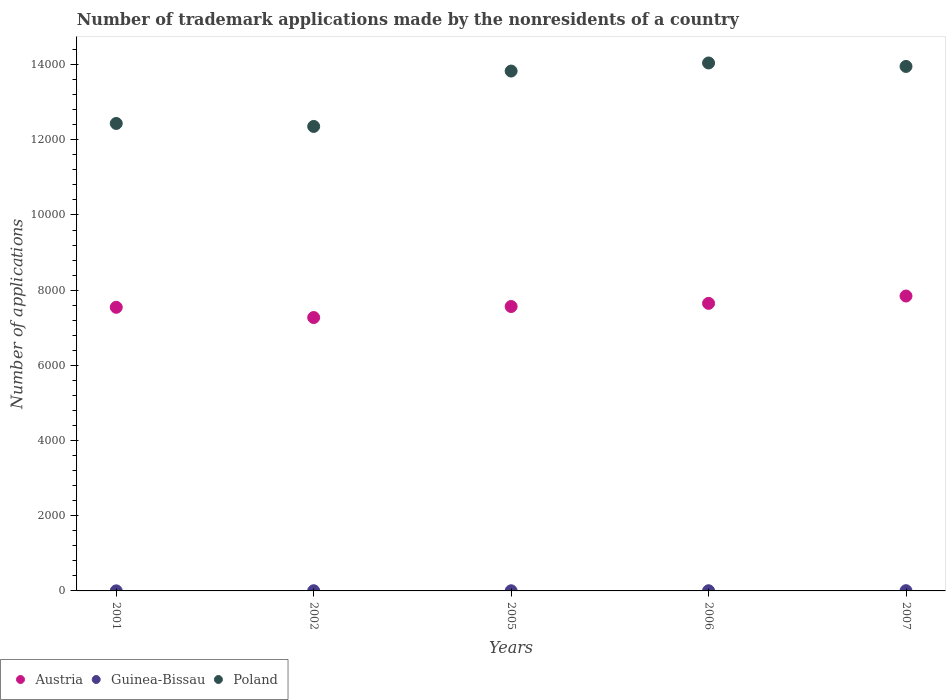Is the number of dotlines equal to the number of legend labels?
Provide a short and direct response. Yes. What is the number of trademark applications made by the nonresidents in Poland in 2001?
Your response must be concise. 1.24e+04. In which year was the number of trademark applications made by the nonresidents in Austria maximum?
Offer a very short reply. 2007. What is the total number of trademark applications made by the nonresidents in Poland in the graph?
Offer a very short reply. 6.66e+04. What is the difference between the number of trademark applications made by the nonresidents in Austria in 2005 and that in 2006?
Your response must be concise. -84. What is the difference between the number of trademark applications made by the nonresidents in Poland in 2005 and the number of trademark applications made by the nonresidents in Austria in 2001?
Provide a succinct answer. 6284. What is the average number of trademark applications made by the nonresidents in Austria per year?
Keep it short and to the point. 7574.8. In the year 2007, what is the difference between the number of trademark applications made by the nonresidents in Guinea-Bissau and number of trademark applications made by the nonresidents in Austria?
Your answer should be very brief. -7838. In how many years, is the number of trademark applications made by the nonresidents in Austria greater than 5200?
Make the answer very short. 5. What is the ratio of the number of trademark applications made by the nonresidents in Poland in 2001 to that in 2007?
Offer a very short reply. 0.89. What is the difference between the highest and the second highest number of trademark applications made by the nonresidents in Guinea-Bissau?
Provide a succinct answer. 1. What is the difference between the highest and the lowest number of trademark applications made by the nonresidents in Austria?
Provide a short and direct response. 572. In how many years, is the number of trademark applications made by the nonresidents in Guinea-Bissau greater than the average number of trademark applications made by the nonresidents in Guinea-Bissau taken over all years?
Make the answer very short. 3. Is the sum of the number of trademark applications made by the nonresidents in Austria in 2005 and 2006 greater than the maximum number of trademark applications made by the nonresidents in Guinea-Bissau across all years?
Your response must be concise. Yes. Is it the case that in every year, the sum of the number of trademark applications made by the nonresidents in Guinea-Bissau and number of trademark applications made by the nonresidents in Austria  is greater than the number of trademark applications made by the nonresidents in Poland?
Provide a short and direct response. No. Is the number of trademark applications made by the nonresidents in Poland strictly less than the number of trademark applications made by the nonresidents in Guinea-Bissau over the years?
Offer a terse response. No. How many dotlines are there?
Ensure brevity in your answer.  3. What is the difference between two consecutive major ticks on the Y-axis?
Make the answer very short. 2000. Does the graph contain any zero values?
Ensure brevity in your answer.  No. How many legend labels are there?
Offer a terse response. 3. How are the legend labels stacked?
Your answer should be very brief. Horizontal. What is the title of the graph?
Your answer should be very brief. Number of trademark applications made by the nonresidents of a country. What is the label or title of the X-axis?
Your response must be concise. Years. What is the label or title of the Y-axis?
Offer a very short reply. Number of applications. What is the Number of applications of Austria in 2001?
Offer a terse response. 7544. What is the Number of applications in Guinea-Bissau in 2001?
Your response must be concise. 2. What is the Number of applications in Poland in 2001?
Your answer should be very brief. 1.24e+04. What is the Number of applications in Austria in 2002?
Make the answer very short. 7272. What is the Number of applications of Poland in 2002?
Provide a succinct answer. 1.24e+04. What is the Number of applications of Austria in 2005?
Give a very brief answer. 7565. What is the Number of applications in Guinea-Bissau in 2005?
Your response must be concise. 4. What is the Number of applications in Poland in 2005?
Make the answer very short. 1.38e+04. What is the Number of applications of Austria in 2006?
Provide a short and direct response. 7649. What is the Number of applications of Guinea-Bissau in 2006?
Keep it short and to the point. 5. What is the Number of applications in Poland in 2006?
Your answer should be very brief. 1.40e+04. What is the Number of applications of Austria in 2007?
Provide a short and direct response. 7844. What is the Number of applications of Poland in 2007?
Your response must be concise. 1.40e+04. Across all years, what is the maximum Number of applications of Austria?
Provide a short and direct response. 7844. Across all years, what is the maximum Number of applications of Poland?
Ensure brevity in your answer.  1.40e+04. Across all years, what is the minimum Number of applications of Austria?
Your answer should be compact. 7272. Across all years, what is the minimum Number of applications in Poland?
Your response must be concise. 1.24e+04. What is the total Number of applications in Austria in the graph?
Provide a short and direct response. 3.79e+04. What is the total Number of applications of Guinea-Bissau in the graph?
Give a very brief answer. 22. What is the total Number of applications in Poland in the graph?
Make the answer very short. 6.66e+04. What is the difference between the Number of applications of Austria in 2001 and that in 2002?
Give a very brief answer. 272. What is the difference between the Number of applications in Guinea-Bissau in 2001 and that in 2002?
Your answer should be very brief. -3. What is the difference between the Number of applications in Poland in 2001 and that in 2002?
Offer a very short reply. 79. What is the difference between the Number of applications in Austria in 2001 and that in 2005?
Give a very brief answer. -21. What is the difference between the Number of applications of Poland in 2001 and that in 2005?
Ensure brevity in your answer.  -1394. What is the difference between the Number of applications in Austria in 2001 and that in 2006?
Make the answer very short. -105. What is the difference between the Number of applications in Guinea-Bissau in 2001 and that in 2006?
Ensure brevity in your answer.  -3. What is the difference between the Number of applications in Poland in 2001 and that in 2006?
Make the answer very short. -1609. What is the difference between the Number of applications of Austria in 2001 and that in 2007?
Provide a short and direct response. -300. What is the difference between the Number of applications of Poland in 2001 and that in 2007?
Provide a succinct answer. -1517. What is the difference between the Number of applications in Austria in 2002 and that in 2005?
Provide a succinct answer. -293. What is the difference between the Number of applications of Guinea-Bissau in 2002 and that in 2005?
Keep it short and to the point. 1. What is the difference between the Number of applications of Poland in 2002 and that in 2005?
Provide a succinct answer. -1473. What is the difference between the Number of applications in Austria in 2002 and that in 2006?
Give a very brief answer. -377. What is the difference between the Number of applications in Poland in 2002 and that in 2006?
Provide a succinct answer. -1688. What is the difference between the Number of applications of Austria in 2002 and that in 2007?
Provide a short and direct response. -572. What is the difference between the Number of applications of Poland in 2002 and that in 2007?
Keep it short and to the point. -1596. What is the difference between the Number of applications of Austria in 2005 and that in 2006?
Provide a succinct answer. -84. What is the difference between the Number of applications in Poland in 2005 and that in 2006?
Keep it short and to the point. -215. What is the difference between the Number of applications of Austria in 2005 and that in 2007?
Provide a succinct answer. -279. What is the difference between the Number of applications of Poland in 2005 and that in 2007?
Your answer should be compact. -123. What is the difference between the Number of applications of Austria in 2006 and that in 2007?
Offer a terse response. -195. What is the difference between the Number of applications in Poland in 2006 and that in 2007?
Provide a short and direct response. 92. What is the difference between the Number of applications in Austria in 2001 and the Number of applications in Guinea-Bissau in 2002?
Offer a terse response. 7539. What is the difference between the Number of applications in Austria in 2001 and the Number of applications in Poland in 2002?
Provide a short and direct response. -4811. What is the difference between the Number of applications in Guinea-Bissau in 2001 and the Number of applications in Poland in 2002?
Ensure brevity in your answer.  -1.24e+04. What is the difference between the Number of applications of Austria in 2001 and the Number of applications of Guinea-Bissau in 2005?
Keep it short and to the point. 7540. What is the difference between the Number of applications in Austria in 2001 and the Number of applications in Poland in 2005?
Keep it short and to the point. -6284. What is the difference between the Number of applications in Guinea-Bissau in 2001 and the Number of applications in Poland in 2005?
Your answer should be very brief. -1.38e+04. What is the difference between the Number of applications in Austria in 2001 and the Number of applications in Guinea-Bissau in 2006?
Your response must be concise. 7539. What is the difference between the Number of applications of Austria in 2001 and the Number of applications of Poland in 2006?
Your answer should be compact. -6499. What is the difference between the Number of applications of Guinea-Bissau in 2001 and the Number of applications of Poland in 2006?
Ensure brevity in your answer.  -1.40e+04. What is the difference between the Number of applications of Austria in 2001 and the Number of applications of Guinea-Bissau in 2007?
Make the answer very short. 7538. What is the difference between the Number of applications of Austria in 2001 and the Number of applications of Poland in 2007?
Provide a short and direct response. -6407. What is the difference between the Number of applications in Guinea-Bissau in 2001 and the Number of applications in Poland in 2007?
Your answer should be compact. -1.39e+04. What is the difference between the Number of applications of Austria in 2002 and the Number of applications of Guinea-Bissau in 2005?
Your response must be concise. 7268. What is the difference between the Number of applications of Austria in 2002 and the Number of applications of Poland in 2005?
Provide a succinct answer. -6556. What is the difference between the Number of applications in Guinea-Bissau in 2002 and the Number of applications in Poland in 2005?
Your response must be concise. -1.38e+04. What is the difference between the Number of applications of Austria in 2002 and the Number of applications of Guinea-Bissau in 2006?
Offer a very short reply. 7267. What is the difference between the Number of applications in Austria in 2002 and the Number of applications in Poland in 2006?
Provide a short and direct response. -6771. What is the difference between the Number of applications of Guinea-Bissau in 2002 and the Number of applications of Poland in 2006?
Offer a terse response. -1.40e+04. What is the difference between the Number of applications in Austria in 2002 and the Number of applications in Guinea-Bissau in 2007?
Ensure brevity in your answer.  7266. What is the difference between the Number of applications in Austria in 2002 and the Number of applications in Poland in 2007?
Keep it short and to the point. -6679. What is the difference between the Number of applications of Guinea-Bissau in 2002 and the Number of applications of Poland in 2007?
Offer a very short reply. -1.39e+04. What is the difference between the Number of applications in Austria in 2005 and the Number of applications in Guinea-Bissau in 2006?
Give a very brief answer. 7560. What is the difference between the Number of applications of Austria in 2005 and the Number of applications of Poland in 2006?
Make the answer very short. -6478. What is the difference between the Number of applications in Guinea-Bissau in 2005 and the Number of applications in Poland in 2006?
Provide a short and direct response. -1.40e+04. What is the difference between the Number of applications of Austria in 2005 and the Number of applications of Guinea-Bissau in 2007?
Give a very brief answer. 7559. What is the difference between the Number of applications of Austria in 2005 and the Number of applications of Poland in 2007?
Make the answer very short. -6386. What is the difference between the Number of applications of Guinea-Bissau in 2005 and the Number of applications of Poland in 2007?
Offer a very short reply. -1.39e+04. What is the difference between the Number of applications in Austria in 2006 and the Number of applications in Guinea-Bissau in 2007?
Provide a short and direct response. 7643. What is the difference between the Number of applications in Austria in 2006 and the Number of applications in Poland in 2007?
Your answer should be compact. -6302. What is the difference between the Number of applications in Guinea-Bissau in 2006 and the Number of applications in Poland in 2007?
Offer a terse response. -1.39e+04. What is the average Number of applications of Austria per year?
Make the answer very short. 7574.8. What is the average Number of applications of Guinea-Bissau per year?
Give a very brief answer. 4.4. What is the average Number of applications in Poland per year?
Ensure brevity in your answer.  1.33e+04. In the year 2001, what is the difference between the Number of applications in Austria and Number of applications in Guinea-Bissau?
Offer a very short reply. 7542. In the year 2001, what is the difference between the Number of applications of Austria and Number of applications of Poland?
Provide a short and direct response. -4890. In the year 2001, what is the difference between the Number of applications in Guinea-Bissau and Number of applications in Poland?
Your response must be concise. -1.24e+04. In the year 2002, what is the difference between the Number of applications of Austria and Number of applications of Guinea-Bissau?
Provide a succinct answer. 7267. In the year 2002, what is the difference between the Number of applications of Austria and Number of applications of Poland?
Give a very brief answer. -5083. In the year 2002, what is the difference between the Number of applications in Guinea-Bissau and Number of applications in Poland?
Provide a succinct answer. -1.24e+04. In the year 2005, what is the difference between the Number of applications of Austria and Number of applications of Guinea-Bissau?
Your response must be concise. 7561. In the year 2005, what is the difference between the Number of applications of Austria and Number of applications of Poland?
Make the answer very short. -6263. In the year 2005, what is the difference between the Number of applications of Guinea-Bissau and Number of applications of Poland?
Make the answer very short. -1.38e+04. In the year 2006, what is the difference between the Number of applications of Austria and Number of applications of Guinea-Bissau?
Make the answer very short. 7644. In the year 2006, what is the difference between the Number of applications of Austria and Number of applications of Poland?
Keep it short and to the point. -6394. In the year 2006, what is the difference between the Number of applications of Guinea-Bissau and Number of applications of Poland?
Your answer should be compact. -1.40e+04. In the year 2007, what is the difference between the Number of applications of Austria and Number of applications of Guinea-Bissau?
Make the answer very short. 7838. In the year 2007, what is the difference between the Number of applications in Austria and Number of applications in Poland?
Offer a very short reply. -6107. In the year 2007, what is the difference between the Number of applications of Guinea-Bissau and Number of applications of Poland?
Offer a very short reply. -1.39e+04. What is the ratio of the Number of applications of Austria in 2001 to that in 2002?
Offer a terse response. 1.04. What is the ratio of the Number of applications in Poland in 2001 to that in 2002?
Ensure brevity in your answer.  1.01. What is the ratio of the Number of applications in Poland in 2001 to that in 2005?
Your answer should be compact. 0.9. What is the ratio of the Number of applications in Austria in 2001 to that in 2006?
Provide a short and direct response. 0.99. What is the ratio of the Number of applications in Guinea-Bissau in 2001 to that in 2006?
Make the answer very short. 0.4. What is the ratio of the Number of applications of Poland in 2001 to that in 2006?
Provide a short and direct response. 0.89. What is the ratio of the Number of applications in Austria in 2001 to that in 2007?
Ensure brevity in your answer.  0.96. What is the ratio of the Number of applications in Guinea-Bissau in 2001 to that in 2007?
Provide a short and direct response. 0.33. What is the ratio of the Number of applications in Poland in 2001 to that in 2007?
Your answer should be compact. 0.89. What is the ratio of the Number of applications in Austria in 2002 to that in 2005?
Keep it short and to the point. 0.96. What is the ratio of the Number of applications of Poland in 2002 to that in 2005?
Your response must be concise. 0.89. What is the ratio of the Number of applications of Austria in 2002 to that in 2006?
Provide a short and direct response. 0.95. What is the ratio of the Number of applications of Guinea-Bissau in 2002 to that in 2006?
Give a very brief answer. 1. What is the ratio of the Number of applications of Poland in 2002 to that in 2006?
Offer a terse response. 0.88. What is the ratio of the Number of applications of Austria in 2002 to that in 2007?
Provide a succinct answer. 0.93. What is the ratio of the Number of applications of Guinea-Bissau in 2002 to that in 2007?
Give a very brief answer. 0.83. What is the ratio of the Number of applications in Poland in 2002 to that in 2007?
Make the answer very short. 0.89. What is the ratio of the Number of applications in Austria in 2005 to that in 2006?
Offer a terse response. 0.99. What is the ratio of the Number of applications in Guinea-Bissau in 2005 to that in 2006?
Provide a short and direct response. 0.8. What is the ratio of the Number of applications of Poland in 2005 to that in 2006?
Your response must be concise. 0.98. What is the ratio of the Number of applications of Austria in 2005 to that in 2007?
Provide a succinct answer. 0.96. What is the ratio of the Number of applications in Guinea-Bissau in 2005 to that in 2007?
Ensure brevity in your answer.  0.67. What is the ratio of the Number of applications in Austria in 2006 to that in 2007?
Your response must be concise. 0.98. What is the ratio of the Number of applications of Poland in 2006 to that in 2007?
Keep it short and to the point. 1.01. What is the difference between the highest and the second highest Number of applications of Austria?
Provide a short and direct response. 195. What is the difference between the highest and the second highest Number of applications in Poland?
Make the answer very short. 92. What is the difference between the highest and the lowest Number of applications of Austria?
Keep it short and to the point. 572. What is the difference between the highest and the lowest Number of applications in Guinea-Bissau?
Offer a terse response. 4. What is the difference between the highest and the lowest Number of applications in Poland?
Ensure brevity in your answer.  1688. 